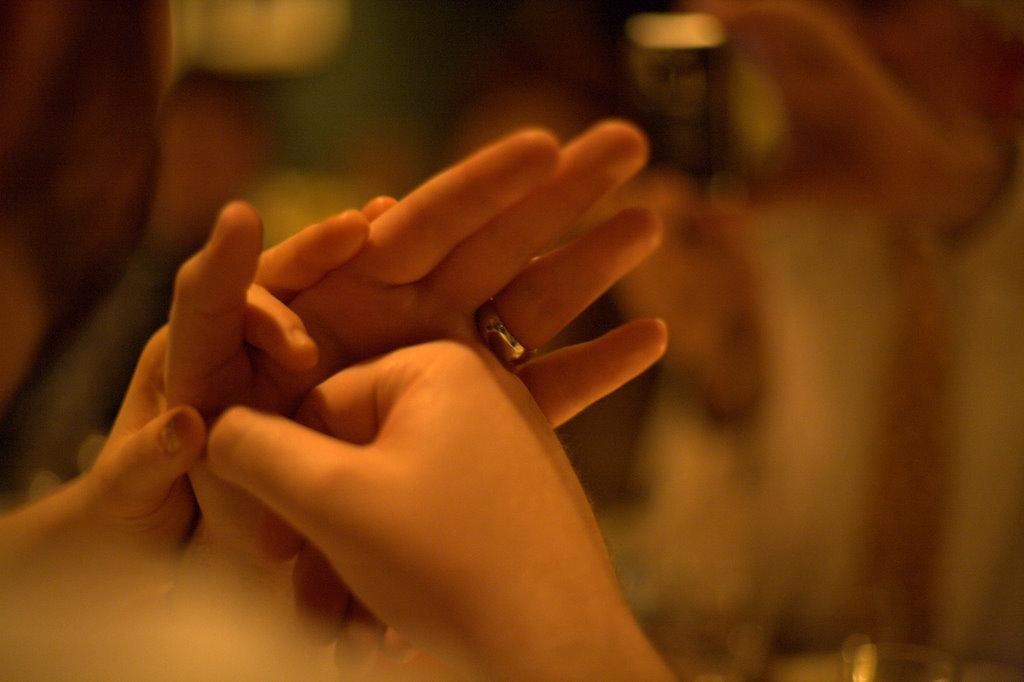What can be seen in the image involving two people? There are hands of two persons in the image. Is there any jewelry visible on the hands? Yes, there is a silver ring on one of the hands. What can be observed in the background of the image? There are blurry objects in the background of the image. What type of suit is the person wearing in the image? There is no person wearing a suit in the image; only hands are visible. Can you tell me how many balls are being held by the hands in the image? There are no balls present in the image; only hands and a silver ring are visible. 